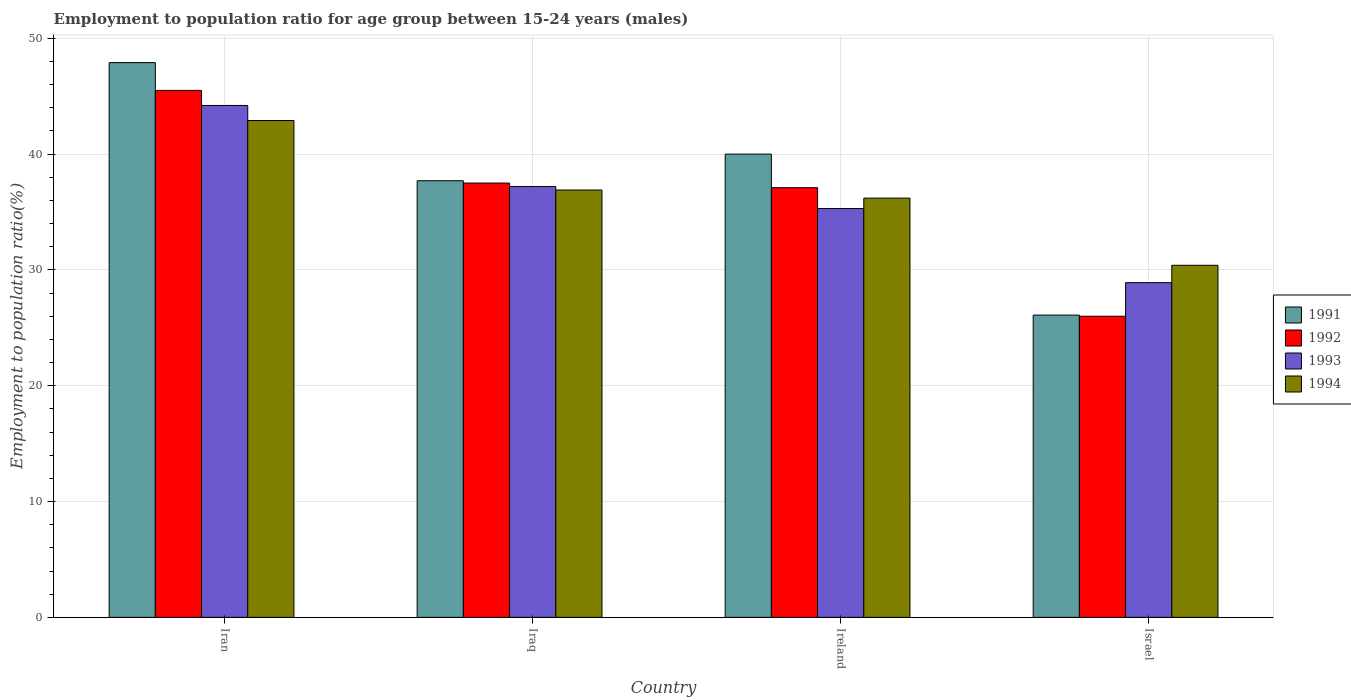How many groups of bars are there?
Your answer should be compact. 4. Are the number of bars per tick equal to the number of legend labels?
Keep it short and to the point. Yes. What is the label of the 1st group of bars from the left?
Your answer should be very brief. Iran. In how many cases, is the number of bars for a given country not equal to the number of legend labels?
Your answer should be very brief. 0. What is the employment to population ratio in 1991 in Iraq?
Make the answer very short. 37.7. Across all countries, what is the maximum employment to population ratio in 1991?
Your answer should be very brief. 47.9. Across all countries, what is the minimum employment to population ratio in 1993?
Provide a short and direct response. 28.9. In which country was the employment to population ratio in 1994 maximum?
Your response must be concise. Iran. In which country was the employment to population ratio in 1991 minimum?
Provide a short and direct response. Israel. What is the total employment to population ratio in 1994 in the graph?
Provide a succinct answer. 146.4. What is the difference between the employment to population ratio in 1993 in Iran and that in Iraq?
Give a very brief answer. 7. What is the difference between the employment to population ratio in 1992 in Ireland and the employment to population ratio in 1994 in Israel?
Offer a terse response. 6.7. What is the average employment to population ratio in 1993 per country?
Keep it short and to the point. 36.4. What is the difference between the employment to population ratio of/in 1992 and employment to population ratio of/in 1991 in Iraq?
Ensure brevity in your answer.  -0.2. In how many countries, is the employment to population ratio in 1994 greater than 42 %?
Your answer should be very brief. 1. What is the ratio of the employment to population ratio in 1994 in Iran to that in Iraq?
Offer a very short reply. 1.16. What is the difference between the highest and the second highest employment to population ratio in 1991?
Provide a succinct answer. 2.3. What is the difference between the highest and the lowest employment to population ratio in 1992?
Offer a very short reply. 19.5. Is it the case that in every country, the sum of the employment to population ratio in 1993 and employment to population ratio in 1992 is greater than the sum of employment to population ratio in 1994 and employment to population ratio in 1991?
Provide a succinct answer. No. What does the 1st bar from the left in Israel represents?
Offer a terse response. 1991. How many bars are there?
Give a very brief answer. 16. Are all the bars in the graph horizontal?
Offer a very short reply. No. Does the graph contain any zero values?
Keep it short and to the point. No. Does the graph contain grids?
Ensure brevity in your answer.  Yes. Where does the legend appear in the graph?
Ensure brevity in your answer.  Center right. What is the title of the graph?
Give a very brief answer. Employment to population ratio for age group between 15-24 years (males). What is the label or title of the X-axis?
Your answer should be compact. Country. What is the label or title of the Y-axis?
Your response must be concise. Employment to population ratio(%). What is the Employment to population ratio(%) of 1991 in Iran?
Offer a very short reply. 47.9. What is the Employment to population ratio(%) in 1992 in Iran?
Offer a terse response. 45.5. What is the Employment to population ratio(%) in 1993 in Iran?
Give a very brief answer. 44.2. What is the Employment to population ratio(%) in 1994 in Iran?
Make the answer very short. 42.9. What is the Employment to population ratio(%) of 1991 in Iraq?
Provide a short and direct response. 37.7. What is the Employment to population ratio(%) of 1992 in Iraq?
Provide a short and direct response. 37.5. What is the Employment to population ratio(%) in 1993 in Iraq?
Your answer should be compact. 37.2. What is the Employment to population ratio(%) in 1994 in Iraq?
Provide a short and direct response. 36.9. What is the Employment to population ratio(%) in 1992 in Ireland?
Offer a terse response. 37.1. What is the Employment to population ratio(%) in 1993 in Ireland?
Keep it short and to the point. 35.3. What is the Employment to population ratio(%) in 1994 in Ireland?
Keep it short and to the point. 36.2. What is the Employment to population ratio(%) in 1991 in Israel?
Offer a very short reply. 26.1. What is the Employment to population ratio(%) in 1993 in Israel?
Ensure brevity in your answer.  28.9. What is the Employment to population ratio(%) of 1994 in Israel?
Ensure brevity in your answer.  30.4. Across all countries, what is the maximum Employment to population ratio(%) in 1991?
Provide a short and direct response. 47.9. Across all countries, what is the maximum Employment to population ratio(%) of 1992?
Provide a succinct answer. 45.5. Across all countries, what is the maximum Employment to population ratio(%) in 1993?
Your answer should be very brief. 44.2. Across all countries, what is the maximum Employment to population ratio(%) in 1994?
Offer a terse response. 42.9. Across all countries, what is the minimum Employment to population ratio(%) in 1991?
Your response must be concise. 26.1. Across all countries, what is the minimum Employment to population ratio(%) of 1992?
Your response must be concise. 26. Across all countries, what is the minimum Employment to population ratio(%) in 1993?
Offer a terse response. 28.9. Across all countries, what is the minimum Employment to population ratio(%) in 1994?
Your answer should be compact. 30.4. What is the total Employment to population ratio(%) in 1991 in the graph?
Make the answer very short. 151.7. What is the total Employment to population ratio(%) in 1992 in the graph?
Your answer should be compact. 146.1. What is the total Employment to population ratio(%) in 1993 in the graph?
Your answer should be compact. 145.6. What is the total Employment to population ratio(%) in 1994 in the graph?
Offer a terse response. 146.4. What is the difference between the Employment to population ratio(%) in 1991 in Iran and that in Iraq?
Your answer should be compact. 10.2. What is the difference between the Employment to population ratio(%) in 1992 in Iran and that in Iraq?
Give a very brief answer. 8. What is the difference between the Employment to population ratio(%) in 1993 in Iran and that in Iraq?
Provide a succinct answer. 7. What is the difference between the Employment to population ratio(%) in 1993 in Iran and that in Ireland?
Your response must be concise. 8.9. What is the difference between the Employment to population ratio(%) of 1994 in Iran and that in Ireland?
Give a very brief answer. 6.7. What is the difference between the Employment to population ratio(%) of 1991 in Iran and that in Israel?
Provide a short and direct response. 21.8. What is the difference between the Employment to population ratio(%) in 1992 in Iran and that in Israel?
Your answer should be very brief. 19.5. What is the difference between the Employment to population ratio(%) of 1992 in Iraq and that in Ireland?
Your response must be concise. 0.4. What is the difference between the Employment to population ratio(%) in 1993 in Iraq and that in Ireland?
Your response must be concise. 1.9. What is the difference between the Employment to population ratio(%) of 1994 in Iraq and that in Ireland?
Keep it short and to the point. 0.7. What is the difference between the Employment to population ratio(%) of 1992 in Iraq and that in Israel?
Your answer should be compact. 11.5. What is the difference between the Employment to population ratio(%) of 1993 in Iraq and that in Israel?
Your response must be concise. 8.3. What is the difference between the Employment to population ratio(%) of 1994 in Iraq and that in Israel?
Offer a very short reply. 6.5. What is the difference between the Employment to population ratio(%) of 1991 in Iran and the Employment to population ratio(%) of 1992 in Iraq?
Provide a succinct answer. 10.4. What is the difference between the Employment to population ratio(%) of 1992 in Iran and the Employment to population ratio(%) of 1994 in Iraq?
Give a very brief answer. 8.6. What is the difference between the Employment to population ratio(%) in 1991 in Iran and the Employment to population ratio(%) in 1993 in Ireland?
Keep it short and to the point. 12.6. What is the difference between the Employment to population ratio(%) in 1992 in Iran and the Employment to population ratio(%) in 1993 in Ireland?
Make the answer very short. 10.2. What is the difference between the Employment to population ratio(%) in 1992 in Iran and the Employment to population ratio(%) in 1994 in Ireland?
Provide a succinct answer. 9.3. What is the difference between the Employment to population ratio(%) in 1991 in Iran and the Employment to population ratio(%) in 1992 in Israel?
Ensure brevity in your answer.  21.9. What is the difference between the Employment to population ratio(%) of 1991 in Iran and the Employment to population ratio(%) of 1993 in Israel?
Make the answer very short. 19. What is the difference between the Employment to population ratio(%) in 1992 in Iran and the Employment to population ratio(%) in 1993 in Israel?
Give a very brief answer. 16.6. What is the difference between the Employment to population ratio(%) of 1992 in Iran and the Employment to population ratio(%) of 1994 in Israel?
Your answer should be compact. 15.1. What is the difference between the Employment to population ratio(%) of 1993 in Iran and the Employment to population ratio(%) of 1994 in Israel?
Keep it short and to the point. 13.8. What is the difference between the Employment to population ratio(%) in 1991 in Iraq and the Employment to population ratio(%) in 1993 in Ireland?
Offer a very short reply. 2.4. What is the difference between the Employment to population ratio(%) of 1992 in Iraq and the Employment to population ratio(%) of 1993 in Ireland?
Make the answer very short. 2.2. What is the difference between the Employment to population ratio(%) in 1992 in Iraq and the Employment to population ratio(%) in 1994 in Ireland?
Your answer should be compact. 1.3. What is the difference between the Employment to population ratio(%) in 1991 in Iraq and the Employment to population ratio(%) in 1993 in Israel?
Provide a succinct answer. 8.8. What is the difference between the Employment to population ratio(%) in 1991 in Iraq and the Employment to population ratio(%) in 1994 in Israel?
Make the answer very short. 7.3. What is the difference between the Employment to population ratio(%) of 1992 in Iraq and the Employment to population ratio(%) of 1994 in Israel?
Your answer should be compact. 7.1. What is the difference between the Employment to population ratio(%) of 1991 in Ireland and the Employment to population ratio(%) of 1992 in Israel?
Offer a terse response. 14. What is the difference between the Employment to population ratio(%) in 1991 in Ireland and the Employment to population ratio(%) in 1994 in Israel?
Your answer should be compact. 9.6. What is the difference between the Employment to population ratio(%) of 1992 in Ireland and the Employment to population ratio(%) of 1993 in Israel?
Offer a very short reply. 8.2. What is the difference between the Employment to population ratio(%) in 1992 in Ireland and the Employment to population ratio(%) in 1994 in Israel?
Give a very brief answer. 6.7. What is the difference between the Employment to population ratio(%) in 1993 in Ireland and the Employment to population ratio(%) in 1994 in Israel?
Offer a very short reply. 4.9. What is the average Employment to population ratio(%) in 1991 per country?
Your answer should be very brief. 37.92. What is the average Employment to population ratio(%) in 1992 per country?
Make the answer very short. 36.52. What is the average Employment to population ratio(%) in 1993 per country?
Your answer should be very brief. 36.4. What is the average Employment to population ratio(%) in 1994 per country?
Give a very brief answer. 36.6. What is the difference between the Employment to population ratio(%) in 1991 and Employment to population ratio(%) in 1993 in Iran?
Give a very brief answer. 3.7. What is the difference between the Employment to population ratio(%) in 1991 and Employment to population ratio(%) in 1994 in Iran?
Offer a terse response. 5. What is the difference between the Employment to population ratio(%) in 1991 and Employment to population ratio(%) in 1992 in Iraq?
Provide a succinct answer. 0.2. What is the difference between the Employment to population ratio(%) of 1991 and Employment to population ratio(%) of 1993 in Iraq?
Give a very brief answer. 0.5. What is the difference between the Employment to population ratio(%) of 1992 and Employment to population ratio(%) of 1993 in Iraq?
Offer a very short reply. 0.3. What is the difference between the Employment to population ratio(%) of 1992 and Employment to population ratio(%) of 1994 in Iraq?
Your response must be concise. 0.6. What is the difference between the Employment to population ratio(%) of 1991 and Employment to population ratio(%) of 1992 in Ireland?
Provide a short and direct response. 2.9. What is the difference between the Employment to population ratio(%) in 1991 and Employment to population ratio(%) in 1993 in Ireland?
Ensure brevity in your answer.  4.7. What is the difference between the Employment to population ratio(%) of 1991 and Employment to population ratio(%) of 1994 in Ireland?
Give a very brief answer. 3.8. What is the difference between the Employment to population ratio(%) of 1991 and Employment to population ratio(%) of 1993 in Israel?
Make the answer very short. -2.8. What is the difference between the Employment to population ratio(%) in 1991 and Employment to population ratio(%) in 1994 in Israel?
Ensure brevity in your answer.  -4.3. What is the difference between the Employment to population ratio(%) of 1993 and Employment to population ratio(%) of 1994 in Israel?
Provide a short and direct response. -1.5. What is the ratio of the Employment to population ratio(%) in 1991 in Iran to that in Iraq?
Your answer should be compact. 1.27. What is the ratio of the Employment to population ratio(%) in 1992 in Iran to that in Iraq?
Provide a succinct answer. 1.21. What is the ratio of the Employment to population ratio(%) of 1993 in Iran to that in Iraq?
Make the answer very short. 1.19. What is the ratio of the Employment to population ratio(%) in 1994 in Iran to that in Iraq?
Your answer should be compact. 1.16. What is the ratio of the Employment to population ratio(%) of 1991 in Iran to that in Ireland?
Ensure brevity in your answer.  1.2. What is the ratio of the Employment to population ratio(%) of 1992 in Iran to that in Ireland?
Your answer should be very brief. 1.23. What is the ratio of the Employment to population ratio(%) of 1993 in Iran to that in Ireland?
Ensure brevity in your answer.  1.25. What is the ratio of the Employment to population ratio(%) in 1994 in Iran to that in Ireland?
Your response must be concise. 1.19. What is the ratio of the Employment to population ratio(%) of 1991 in Iran to that in Israel?
Offer a terse response. 1.84. What is the ratio of the Employment to population ratio(%) in 1993 in Iran to that in Israel?
Provide a succinct answer. 1.53. What is the ratio of the Employment to population ratio(%) in 1994 in Iran to that in Israel?
Ensure brevity in your answer.  1.41. What is the ratio of the Employment to population ratio(%) in 1991 in Iraq to that in Ireland?
Make the answer very short. 0.94. What is the ratio of the Employment to population ratio(%) in 1992 in Iraq to that in Ireland?
Your response must be concise. 1.01. What is the ratio of the Employment to population ratio(%) in 1993 in Iraq to that in Ireland?
Ensure brevity in your answer.  1.05. What is the ratio of the Employment to population ratio(%) of 1994 in Iraq to that in Ireland?
Keep it short and to the point. 1.02. What is the ratio of the Employment to population ratio(%) in 1991 in Iraq to that in Israel?
Offer a terse response. 1.44. What is the ratio of the Employment to population ratio(%) in 1992 in Iraq to that in Israel?
Offer a very short reply. 1.44. What is the ratio of the Employment to population ratio(%) of 1993 in Iraq to that in Israel?
Give a very brief answer. 1.29. What is the ratio of the Employment to population ratio(%) of 1994 in Iraq to that in Israel?
Your response must be concise. 1.21. What is the ratio of the Employment to population ratio(%) in 1991 in Ireland to that in Israel?
Your answer should be very brief. 1.53. What is the ratio of the Employment to population ratio(%) in 1992 in Ireland to that in Israel?
Offer a terse response. 1.43. What is the ratio of the Employment to population ratio(%) in 1993 in Ireland to that in Israel?
Your response must be concise. 1.22. What is the ratio of the Employment to population ratio(%) in 1994 in Ireland to that in Israel?
Provide a succinct answer. 1.19. What is the difference between the highest and the second highest Employment to population ratio(%) in 1992?
Keep it short and to the point. 8. What is the difference between the highest and the second highest Employment to population ratio(%) of 1993?
Provide a succinct answer. 7. What is the difference between the highest and the second highest Employment to population ratio(%) of 1994?
Provide a succinct answer. 6. What is the difference between the highest and the lowest Employment to population ratio(%) of 1991?
Offer a terse response. 21.8. What is the difference between the highest and the lowest Employment to population ratio(%) in 1994?
Your answer should be very brief. 12.5. 